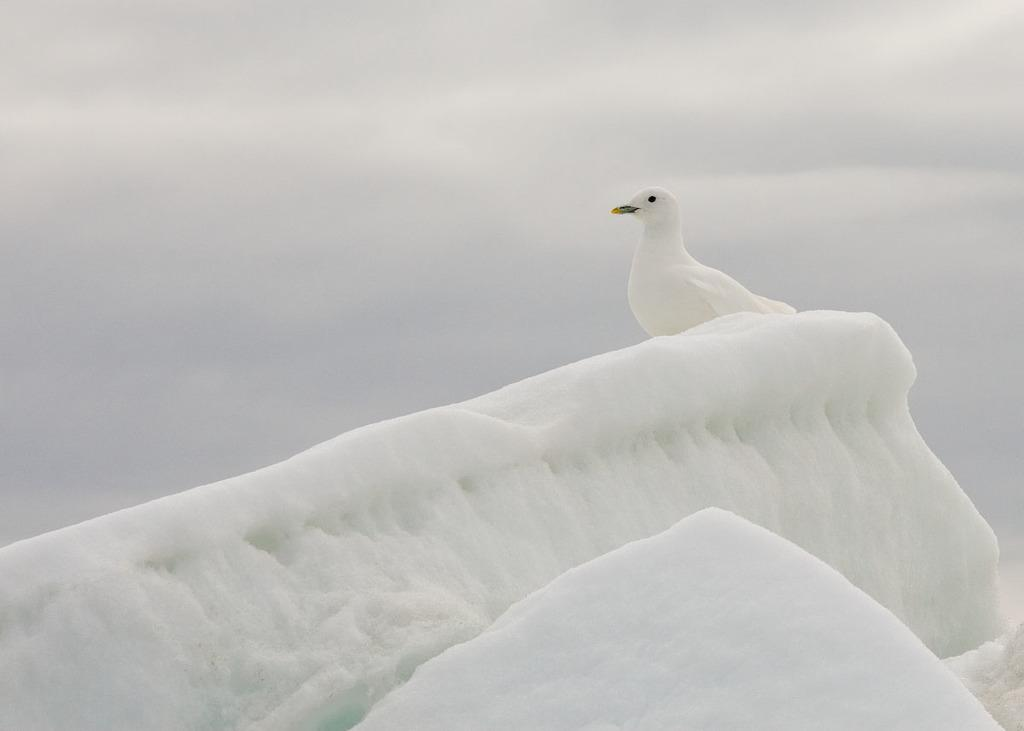What type of bird is in the image? There is a white pigeon in the image. What is the ground covered with in the image? There is snow in the image. How would you describe the sky in the image? The sky is cloudy in the image. What type of locket can be seen hanging from the pigeon's neck in the image? There is no locket present in the image; it features a white pigeon in the snow with a cloudy sky. What is the rate at which the zebra is running in the image? There is no zebra present in the image, so it is not possible to determine the rate at which it might be running. 